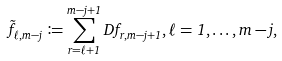Convert formula to latex. <formula><loc_0><loc_0><loc_500><loc_500>\tilde { f } _ { \ell , m - j } \coloneqq \sum _ { r = \ell + 1 } ^ { m - j + 1 } D f _ { r , m - j + 1 } , \ell = 1 , \dots , m - j ,</formula> 